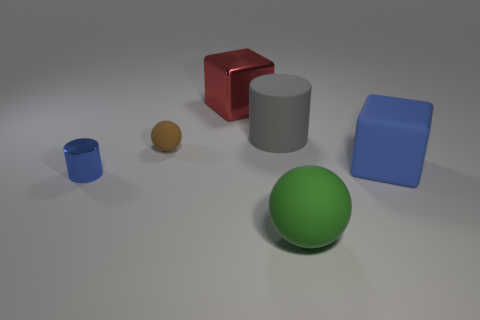Add 1 shiny cubes. How many objects exist? 7 Subtract all balls. How many objects are left? 4 Subtract all red cylinders. Subtract all brown blocks. How many cylinders are left? 2 Subtract all green spheres. How many yellow cylinders are left? 0 Subtract all red cubes. Subtract all big blue cubes. How many objects are left? 4 Add 6 cylinders. How many cylinders are left? 8 Add 2 tiny balls. How many tiny balls exist? 3 Subtract 0 gray spheres. How many objects are left? 6 Subtract 1 blocks. How many blocks are left? 1 